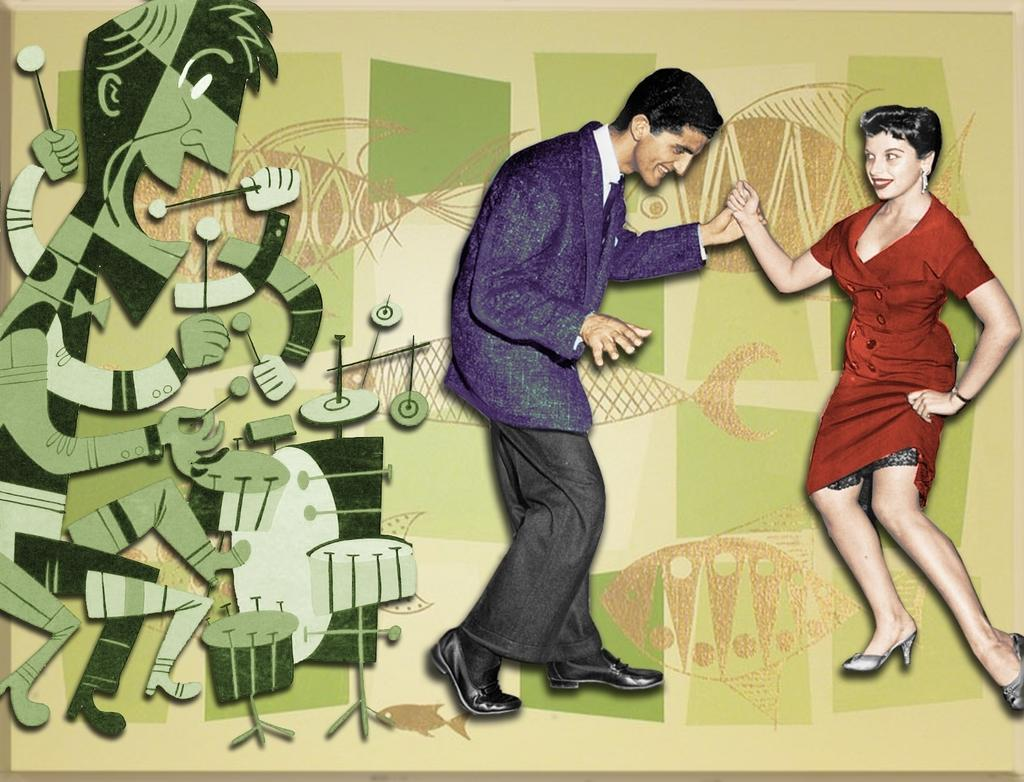How many people are in the image? There are two persons in the image. What can be seen in the background of the image? There is a big wall in the image. What is special about the wall in the image? The wall is painted with pictures. What type of tax is being discussed by the two persons in the image? There is no indication in the image that the two persons are discussing any type of tax. 